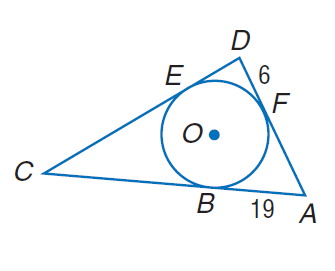Answer the mathemtical geometry problem and directly provide the correct option letter.
Question: Triangle A D C is circumscribed about \odot O. Find the perimeter of \triangle A D C if E C = D E + A F.
Choices: A: 6 B: 19 C: 25 D: 100 D 